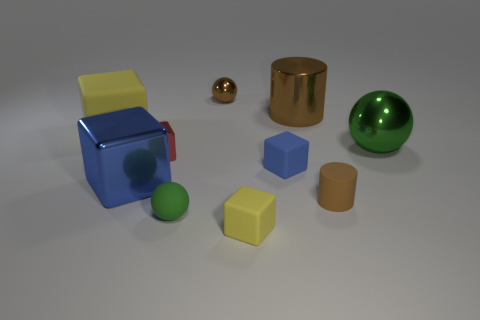Subtract all cylinders. How many objects are left? 8 Subtract all green balls. How many balls are left? 1 Subtract all tiny red blocks. How many blocks are left? 4 Subtract 1 balls. How many balls are left? 2 Subtract all yellow cubes. How many yellow balls are left? 0 Add 7 big metallic things. How many big metallic things are left? 10 Add 6 large purple objects. How many large purple objects exist? 6 Subtract 0 gray balls. How many objects are left? 10 Subtract all purple balls. Subtract all green cubes. How many balls are left? 3 Subtract all small red metallic cubes. Subtract all large red blocks. How many objects are left? 9 